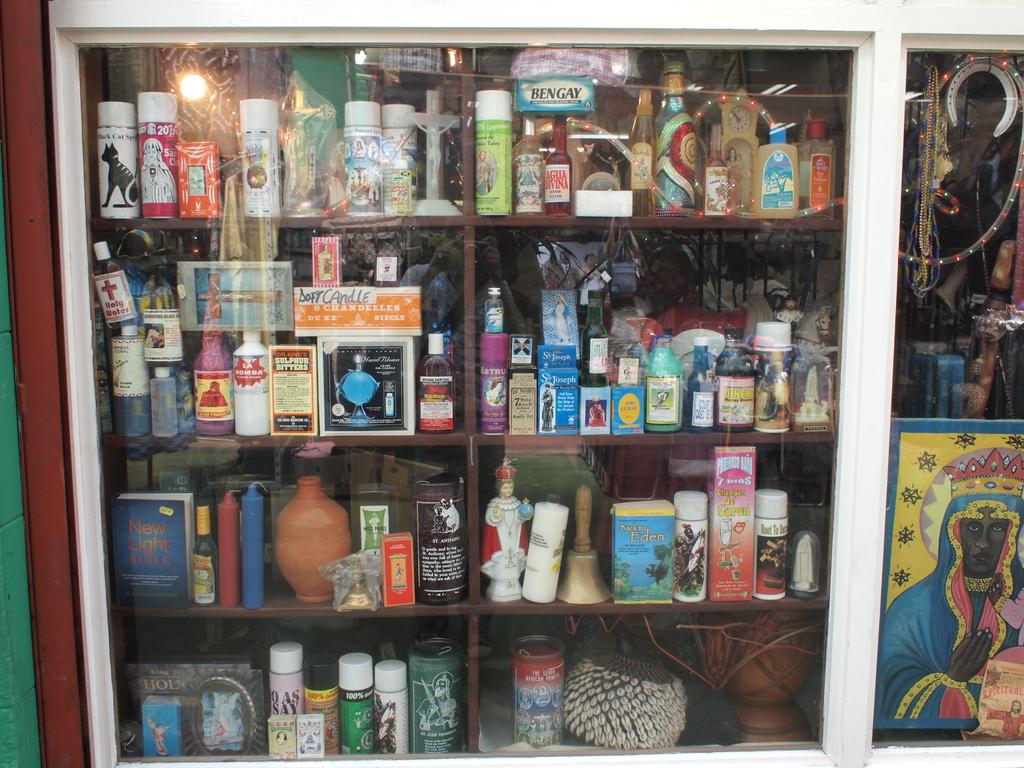Is there any bengay on the top shelf?
Give a very brief answer. Yes. What kind of bible is the blue book on the bottom left?
Provide a short and direct response. New light. 